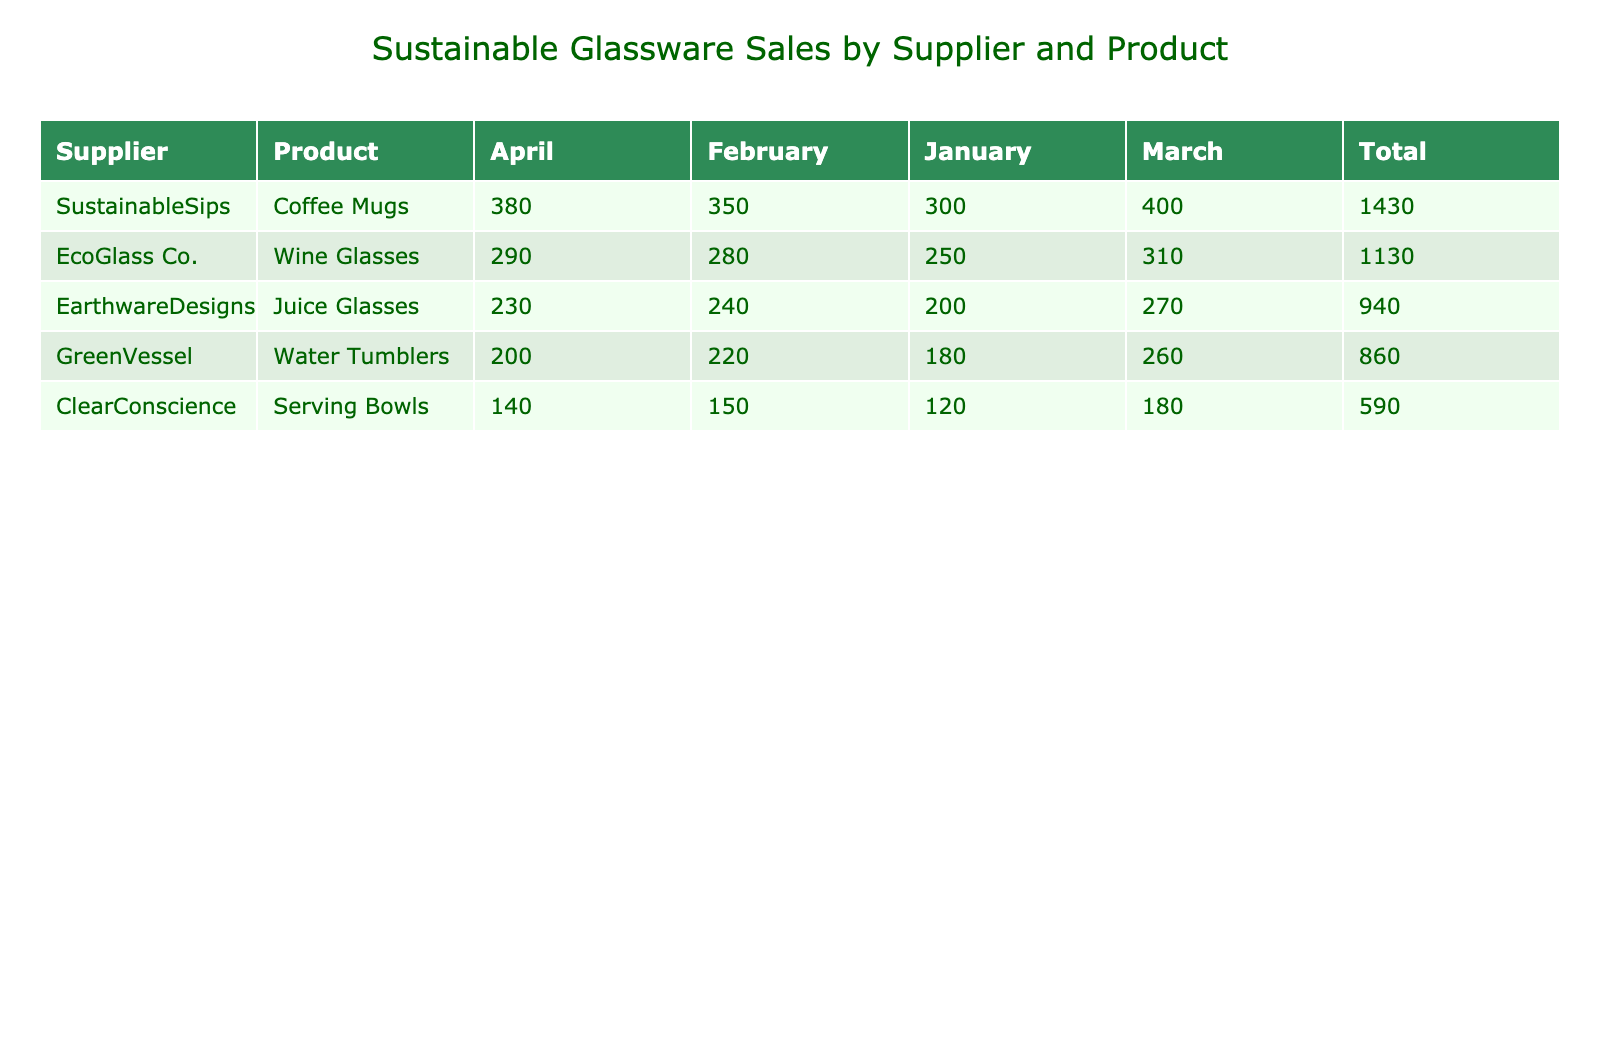What is the total number of units sold for EcoGlass Co. wine glasses? To find the total units sold for EcoGlass Co. wine glasses, we look at the corresponding row in the table and sum the values across all months. The values are 250 (January), 280 (February), 310 (March), and 290 (April), so we calculate 250 + 280 + 310 + 290 = 1130.
Answer: 1130 Which product had the highest total sales across all months? We need to check the total sales for each product. From the table, we see the Total column values: Wine Glasses (1130), Water Tumblers (860), Coffee Mugs (1430), Serving Bowls (590), and Juice Glasses (940). The highest total is for Coffee Mugs, which has 1430 units sold.
Answer: Coffee Mugs Did any supplier's products receive a customer rating of 4.9? We scan the customer ratings column and find that Sustainable Sips received a rating of 4.9 for their Coffee Mugs in February. Therefore, yes, there is a supplier with a product rated 4.9.
Answer: Yes What is the average price per unit for ClearConscience products? We find the prices for ClearConscience products: Serving Bowls (29.99 for January), (29.99 for February), (29.99 for March), and (29.99 for April). Since the price per unit doesn't change, the average price is (29.99 + 29.99 + 29.99 + 29.99)/4 = 29.99.
Answer: 29.99 What is the lead time difference between GreenVessel's Water Tumblers and EcoGlass Co.'s Wine Glasses? We look at the lead times for GreenVessel's Water Tumblers (10, 9, 8, 11 days) and EcoGlass Co.'s Wine Glasses (14, 15, 13, 14 days). The average lead time for Water Tumblers is (10 + 9 + 8 + 11)/4 = 9.5 days and for Wine Glasses is (14 + 15 + 13 + 14)/4 = 14 days. The difference is 14 - 9.5 = 4.5 days.
Answer: 4.5 days 